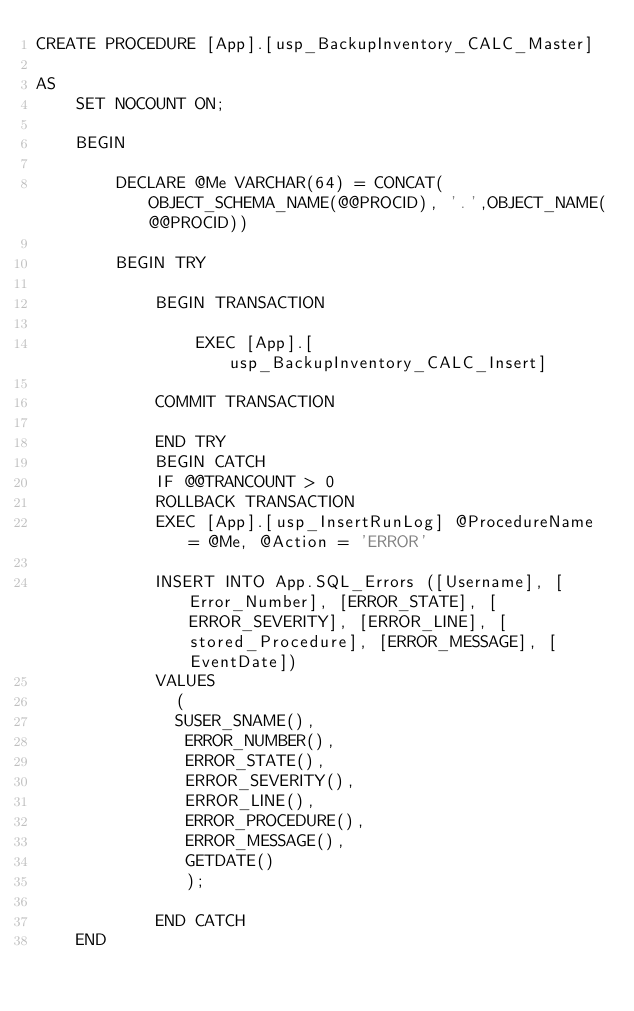<code> <loc_0><loc_0><loc_500><loc_500><_SQL_>CREATE PROCEDURE [App].[usp_BackupInventory_CALC_Master]

AS
	SET NOCOUNT ON;

	BEGIN

		DECLARE @Me VARCHAR(64) = CONCAT(OBJECT_SCHEMA_NAME(@@PROCID), '.',OBJECT_NAME(@@PROCID))

		BEGIN TRY
			
			BEGIN TRANSACTION

				EXEC [App].[usp_BackupInventory_CALC_Insert]

			COMMIT TRANSACTION

			END TRY
			BEGIN CATCH
			IF @@TRANCOUNT > 0 
			ROLLBACK TRANSACTION
			EXEC [App].[usp_InsertRunLog] @ProcedureName = @Me, @Action = 'ERROR'

			INSERT INTO App.SQL_Errors ([Username], [Error_Number], [ERROR_STATE], [ERROR_SEVERITY], [ERROR_LINE], [stored_Procedure], [ERROR_MESSAGE], [EventDate])
			VALUES
			  (
			  SUSER_SNAME(),
			   ERROR_NUMBER(),
			   ERROR_STATE(),
			   ERROR_SEVERITY(),
			   ERROR_LINE(),
			   ERROR_PROCEDURE(),
			   ERROR_MESSAGE(),
			   GETDATE()
			   );

			END CATCH
	END</code> 